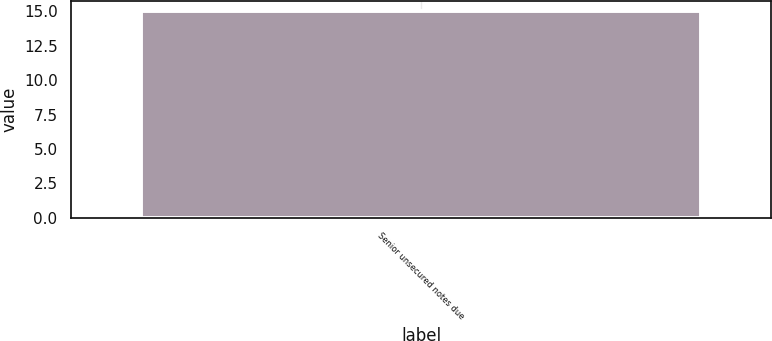<chart> <loc_0><loc_0><loc_500><loc_500><bar_chart><fcel>Senior unsecured notes due<nl><fcel>15<nl></chart> 